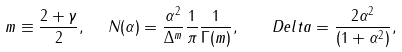<formula> <loc_0><loc_0><loc_500><loc_500>m \equiv \frac { 2 + \gamma } { 2 } , \ \ N ( \alpha ) = \frac { \alpha ^ { 2 } } { \Delta ^ { m } } \frac { 1 } { \pi } \frac { 1 } { \Gamma ( m ) } , \ \ \ D e l t a = \frac { 2 \alpha ^ { 2 } } { ( 1 + \alpha ^ { 2 } ) } ,</formula> 